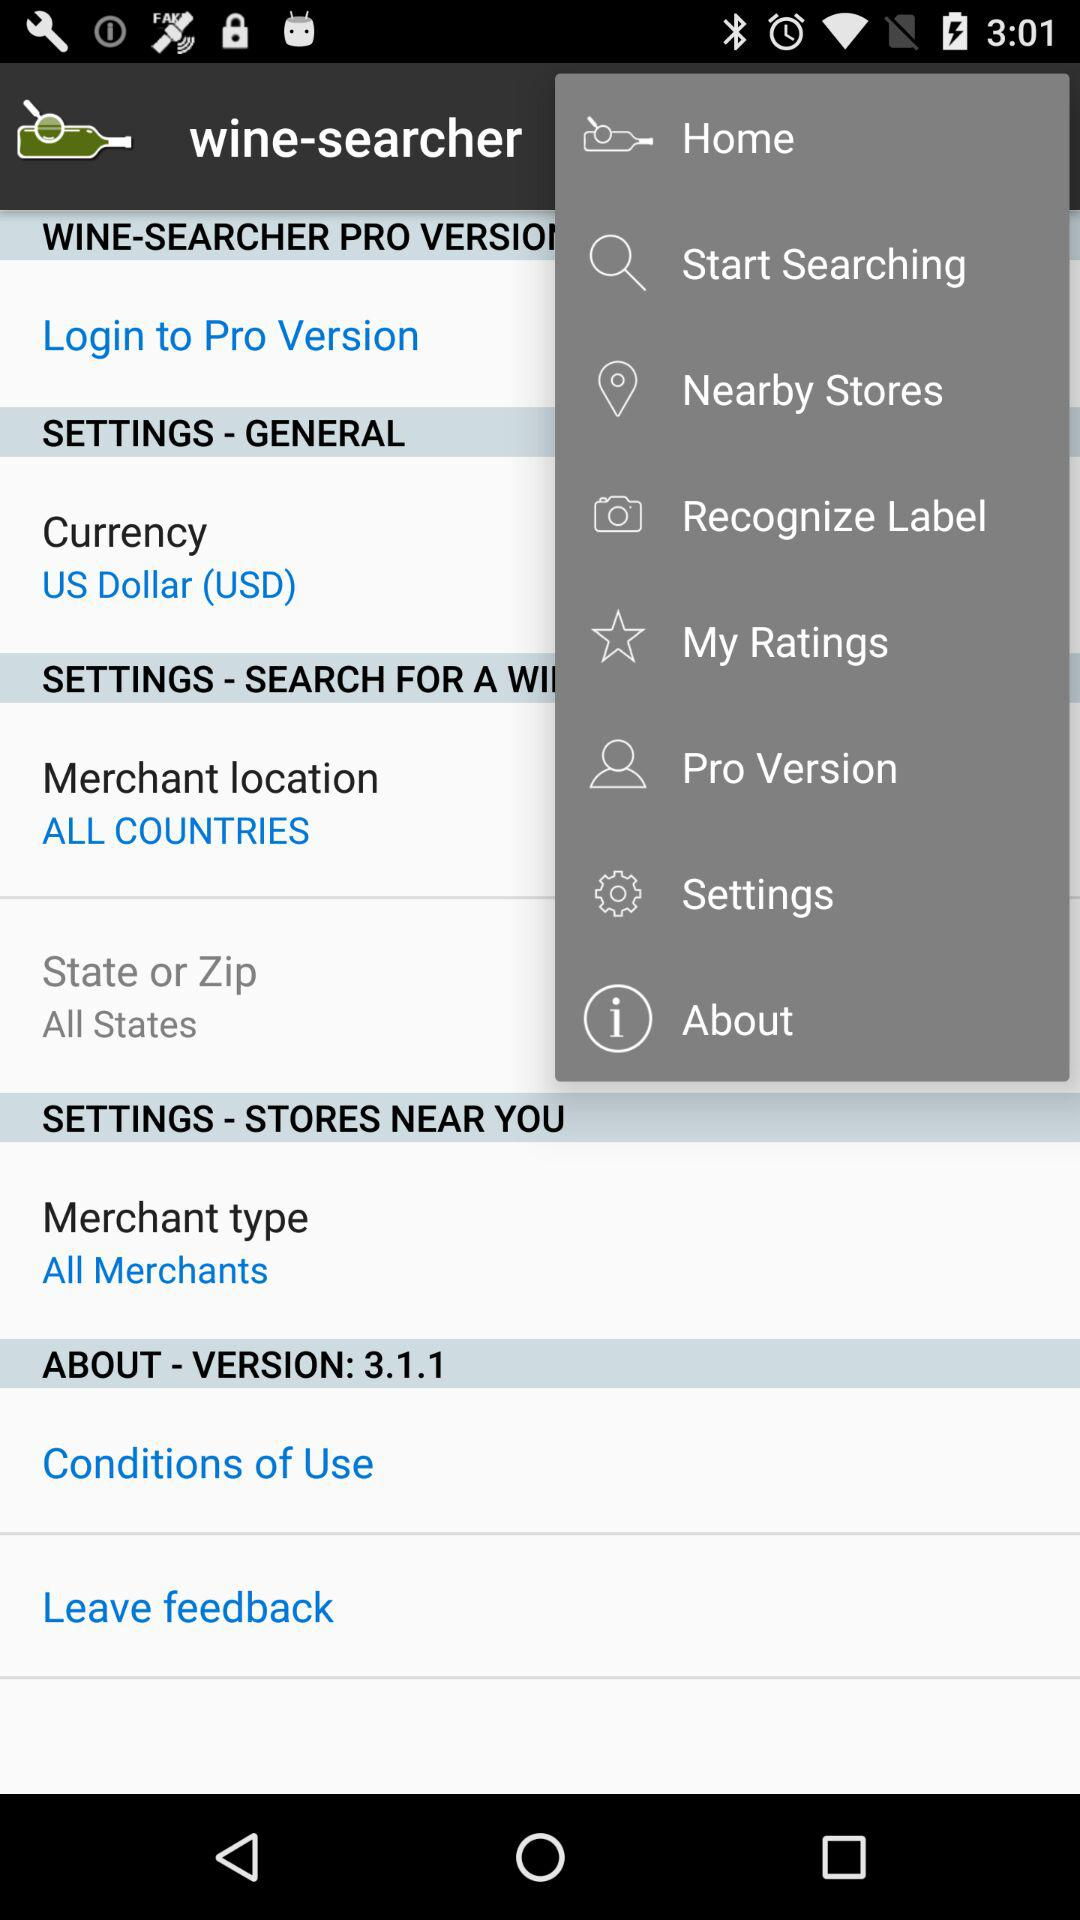What is the name of the application? The name of the application is "wine-searcher". 